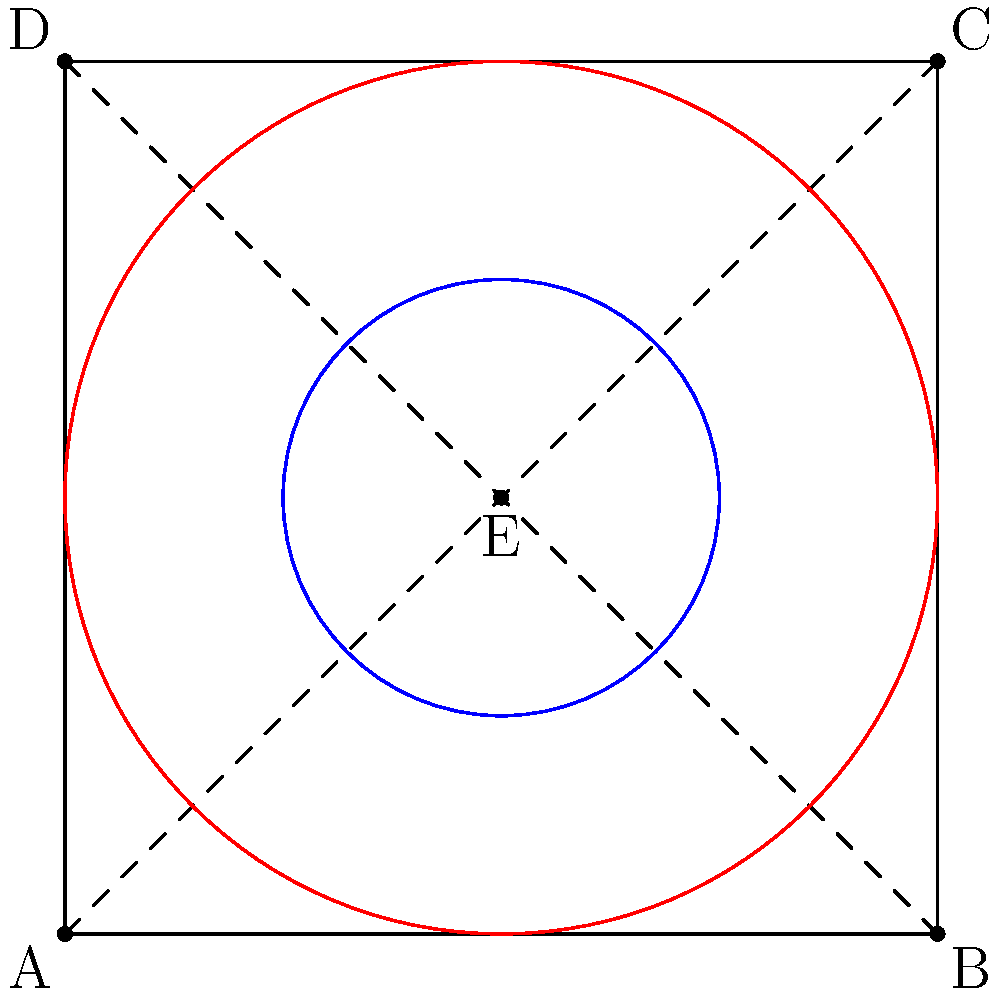You're designing a symmetrical album cover for your glam-rock inspired debut. The design is based on a square with two intersecting diagonal lines and two concentric circles at its center, as shown in the figure. If you apply a 90° rotation followed by a reflection across the vertical line passing through the center, what series of transformations would bring the design back to its original position? Let's approach this step-by-step:

1) First, we apply a 90° rotation clockwise around the center point E. This moves:
   A → B, B → C, C → D, D → A
   The circles remain unchanged.

2) Then, we reflect across the vertical line passing through E. This moves:
   B → A, C → D, A → B, D → C
   The circles remain unchanged.

3) To bring the design back to its original position, we need to undo these transformations in reverse order:

   a) First, apply another reflection across the vertical line through E.
      This will undo the previous reflection.

   b) Then, apply a 270° rotation clockwise (or 90° counterclockwise) around E.
      This will undo the initial 90° clockwise rotation.

4) We can simplify this sequence:
   - Two reflections across the same line cancel each other out.
   - A 270° clockwise rotation is equivalent to a 90° counterclockwise rotation.

5) Therefore, the final sequence to return to the original position is simply:
   A 90° counterclockwise rotation around the center point E.

This single transformation is equivalent to the composite of the two reverse transformations and will bring the design back to its original position.
Answer: 90° counterclockwise rotation around the center 